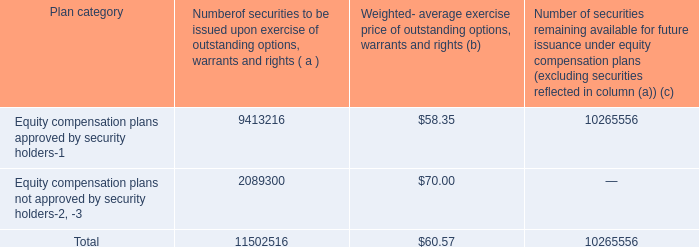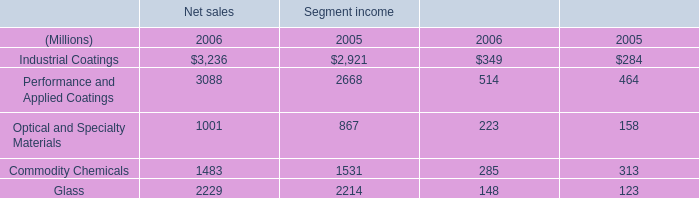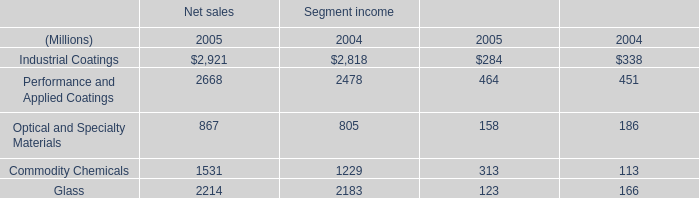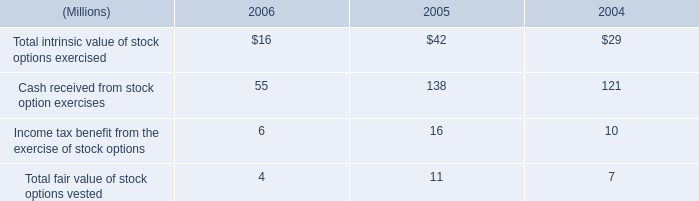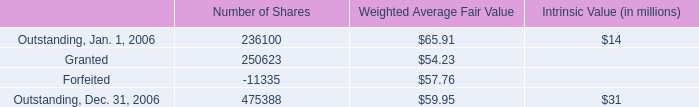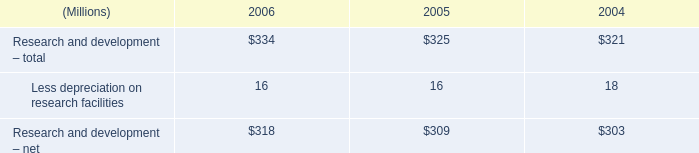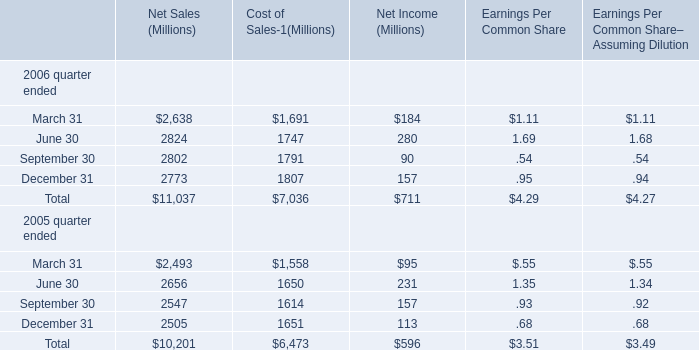what was the change in earnings per share from 2005 to 2006? 
Computations: (4.27 - 3.49)
Answer: 0.78. 